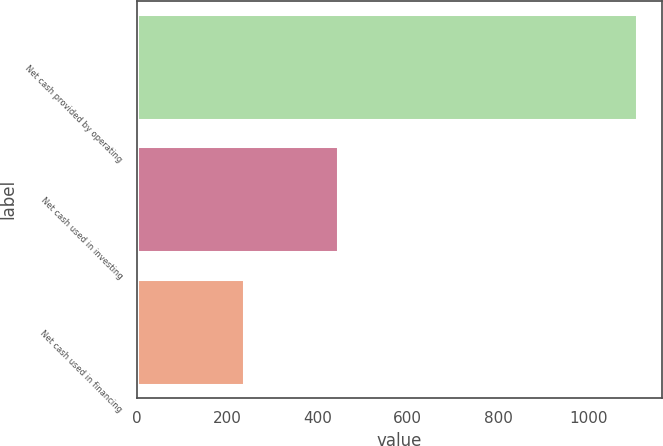Convert chart. <chart><loc_0><loc_0><loc_500><loc_500><bar_chart><fcel>Net cash provided by operating<fcel>Net cash used in investing<fcel>Net cash used in financing<nl><fcel>1107.2<fcel>444.6<fcel>236.3<nl></chart> 